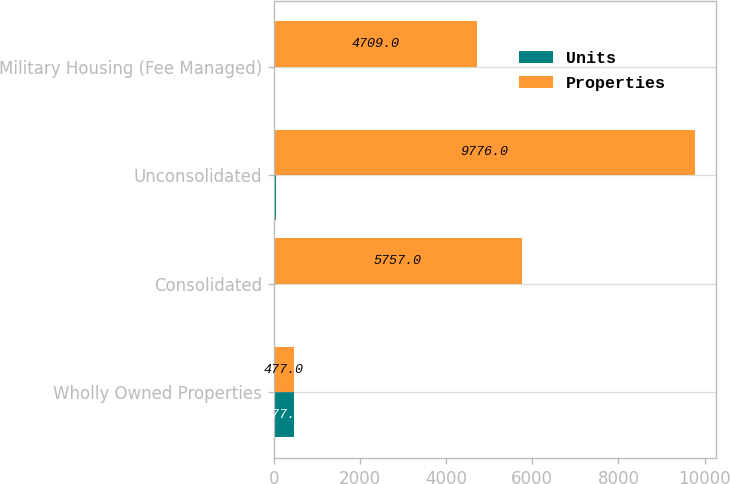<chart> <loc_0><loc_0><loc_500><loc_500><stacked_bar_chart><ecel><fcel>Wholly Owned Properties<fcel>Consolidated<fcel>Unconsolidated<fcel>Military Housing (Fee Managed)<nl><fcel>Units<fcel>477<fcel>28<fcel>41<fcel>2<nl><fcel>Properties<fcel>477<fcel>5757<fcel>9776<fcel>4709<nl></chart> 